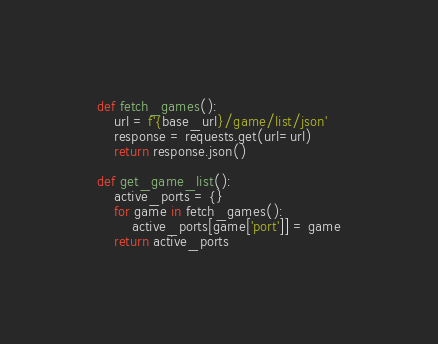Convert code to text. <code><loc_0><loc_0><loc_500><loc_500><_Python_>def fetch_games():
    url = f'{base_url}/game/list/json'
    response = requests.get(url=url)
    return response.json()

def get_game_list():
    active_ports = {}
    for game in fetch_games():
        active_ports[game['port']] = game
    return active_ports
</code> 